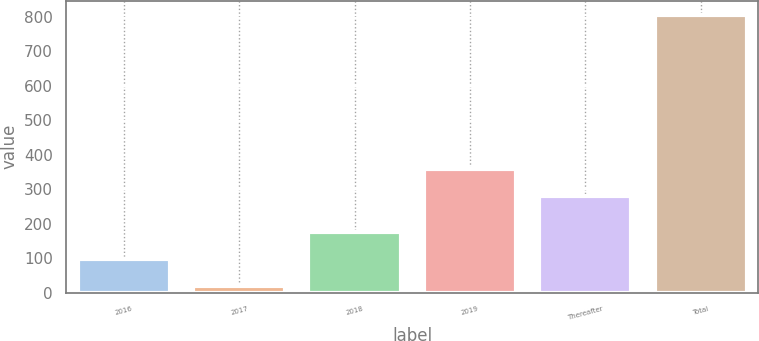Convert chart to OTSL. <chart><loc_0><loc_0><loc_500><loc_500><bar_chart><fcel>2016<fcel>2017<fcel>2018<fcel>2019<fcel>Thereafter<fcel>Total<nl><fcel>97.83<fcel>19<fcel>176.66<fcel>358.83<fcel>280<fcel>807.3<nl></chart> 